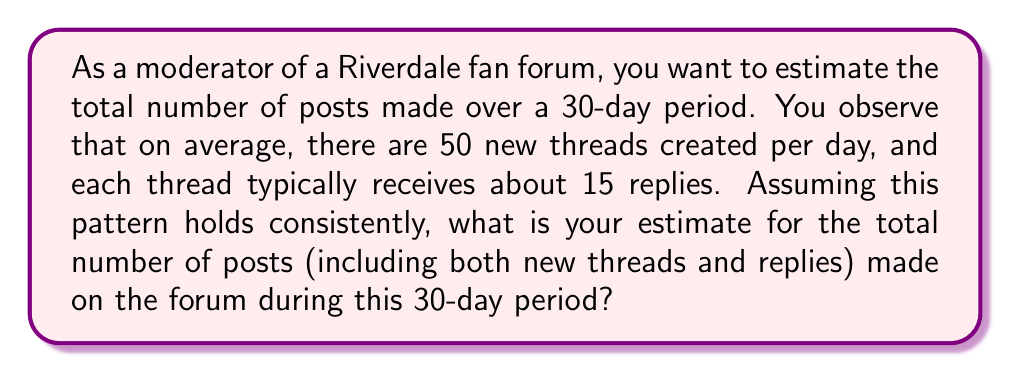Can you answer this question? Let's break this down step-by-step:

1. Calculate the number of new threads in 30 days:
   $$ \text{New threads} = 50 \text{ threads/day} \times 30 \text{ days} = 1500 \text{ threads} $$

2. Calculate the number of replies for these threads:
   $$ \text{Replies} = 1500 \text{ threads} \times 15 \text{ replies/thread} = 22500 \text{ replies} $$

3. The total number of posts is the sum of new threads and replies:
   $$ \text{Total posts} = \text{New threads} + \text{Replies} $$
   $$ \text{Total posts} = 1500 + 22500 = 24000 \text{ posts} $$

Therefore, the estimated total number of posts in the Riverdale fan forum over the 30-day period is 24,000.
Answer: 24,000 posts 